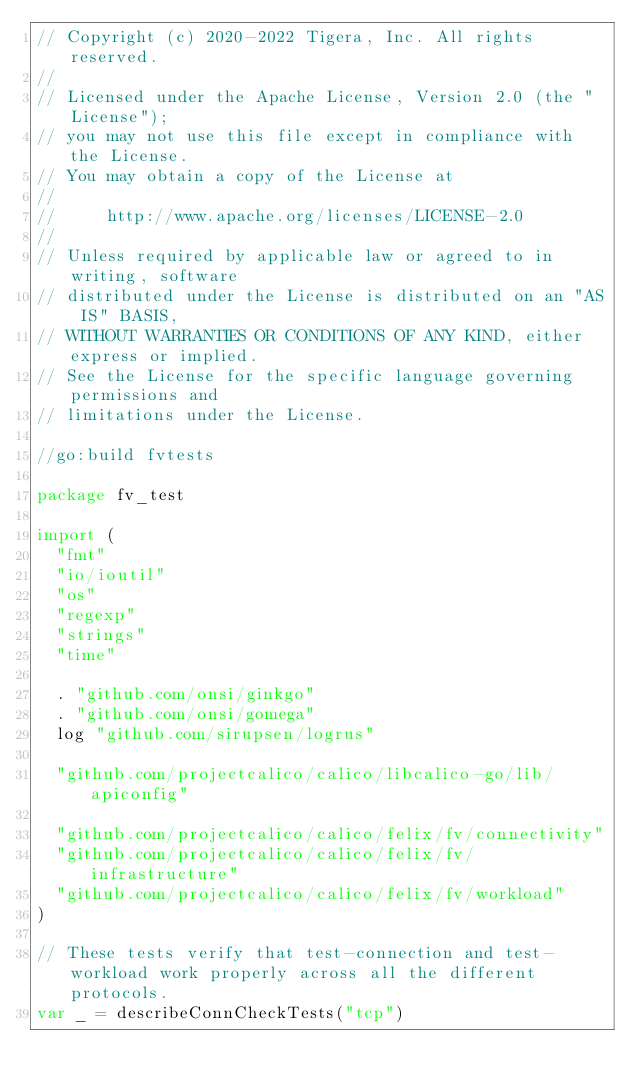<code> <loc_0><loc_0><loc_500><loc_500><_Go_>// Copyright (c) 2020-2022 Tigera, Inc. All rights reserved.
//
// Licensed under the Apache License, Version 2.0 (the "License");
// you may not use this file except in compliance with the License.
// You may obtain a copy of the License at
//
//     http://www.apache.org/licenses/LICENSE-2.0
//
// Unless required by applicable law or agreed to in writing, software
// distributed under the License is distributed on an "AS IS" BASIS,
// WITHOUT WARRANTIES OR CONDITIONS OF ANY KIND, either express or implied.
// See the License for the specific language governing permissions and
// limitations under the License.

//go:build fvtests

package fv_test

import (
	"fmt"
	"io/ioutil"
	"os"
	"regexp"
	"strings"
	"time"

	. "github.com/onsi/ginkgo"
	. "github.com/onsi/gomega"
	log "github.com/sirupsen/logrus"

	"github.com/projectcalico/calico/libcalico-go/lib/apiconfig"

	"github.com/projectcalico/calico/felix/fv/connectivity"
	"github.com/projectcalico/calico/felix/fv/infrastructure"
	"github.com/projectcalico/calico/felix/fv/workload"
)

// These tests verify that test-connection and test-workload work properly across all the different protocols.
var _ = describeConnCheckTests("tcp")</code> 